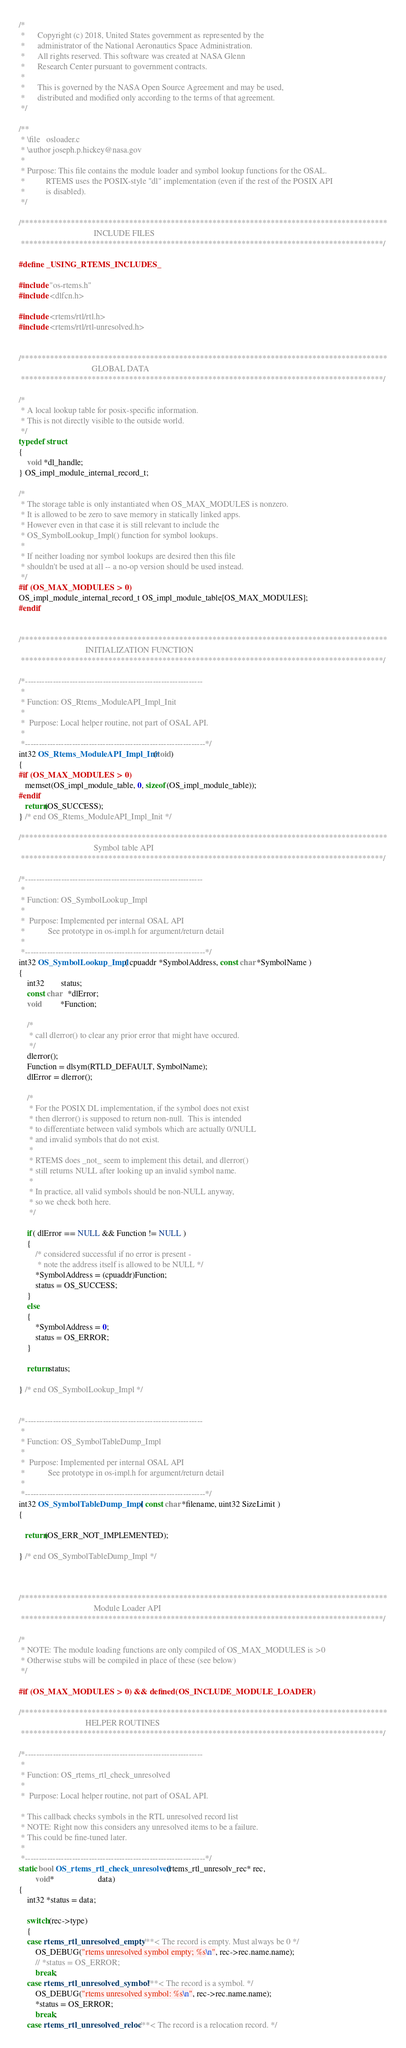<code> <loc_0><loc_0><loc_500><loc_500><_C_>/*
 *      Copyright (c) 2018, United States government as represented by the
 *      administrator of the National Aeronautics Space Administration.
 *      All rights reserved. This software was created at NASA Glenn
 *      Research Center pursuant to government contracts.
 *
 *      This is governed by the NASA Open Source Agreement and may be used,
 *      distributed and modified only according to the terms of that agreement.
 */

/**
 * \file   osloader.c
 * \author joseph.p.hickey@nasa.gov
 *
 * Purpose: This file contains the module loader and symbol lookup functions for the OSAL.
 *          RTEMS uses the POSIX-style "dl" implementation (even if the rest of the POSIX API
 *          is disabled).
 */

/****************************************************************************************
                                    INCLUDE FILES
 ***************************************************************************************/

#define _USING_RTEMS_INCLUDES_

#include "os-rtems.h"
#include <dlfcn.h>

#include <rtems/rtl/rtl.h>
#include <rtems/rtl/rtl-unresolved.h>


/****************************************************************************************
                                   GLOBAL DATA
 ***************************************************************************************/

/*
 * A local lookup table for posix-specific information.
 * This is not directly visible to the outside world.
 */
typedef struct
{
    void *dl_handle;
} OS_impl_module_internal_record_t;

/*
 * The storage table is only instantiated when OS_MAX_MODULES is nonzero.
 * It is allowed to be zero to save memory in statically linked apps.
 * However even in that case it is still relevant to include the
 * OS_SymbolLookup_Impl() function for symbol lookups.
 *
 * If neither loading nor symbol lookups are desired then this file
 * shouldn't be used at all -- a no-op version should be used instead.
 */
#if (OS_MAX_MODULES > 0)
OS_impl_module_internal_record_t OS_impl_module_table[OS_MAX_MODULES];
#endif


/****************************************************************************************
                                INITIALIZATION FUNCTION
 ***************************************************************************************/
                        
/*----------------------------------------------------------------
 *
 * Function: OS_Rtems_ModuleAPI_Impl_Init
 *
 *  Purpose: Local helper routine, not part of OSAL API.
 *
 *-----------------------------------------------------------------*/
int32 OS_Rtems_ModuleAPI_Impl_Init(void)
{
#if (OS_MAX_MODULES > 0)
   memset(OS_impl_module_table, 0, sizeof(OS_impl_module_table));
#endif
   return(OS_SUCCESS);
} /* end OS_Rtems_ModuleAPI_Impl_Init */

/****************************************************************************************
                                    Symbol table API
 ***************************************************************************************/
                        
/*----------------------------------------------------------------
 *
 * Function: OS_SymbolLookup_Impl
 *
 *  Purpose: Implemented per internal OSAL API
 *           See prototype in os-impl.h for argument/return detail
 *
 *-----------------------------------------------------------------*/
int32 OS_SymbolLookup_Impl( cpuaddr *SymbolAddress, const char *SymbolName )
{
    int32        status;
    const char   *dlError;
    void         *Function;

    /*
     * call dlerror() to clear any prior error that might have occured.
     */
    dlerror();
    Function = dlsym(RTLD_DEFAULT, SymbolName);
    dlError = dlerror();

    /*
     * For the POSIX DL implementation, if the symbol does not exist
     * then dlerror() is supposed to return non-null.  This is intended
     * to differentiate between valid symbols which are actually 0/NULL
     * and invalid symbols that do not exist.
     *
     * RTEMS does _not_ seem to implement this detail, and dlerror()
     * still returns NULL after looking up an invalid symbol name.
     *
     * In practice, all valid symbols should be non-NULL anyway,
     * so we check both here.
     */

    if( dlError == NULL && Function != NULL )
    {
        /* considered successful if no error is present -
         * note the address itself is allowed to be NULL */
        *SymbolAddress = (cpuaddr)Function;
        status = OS_SUCCESS;
    }
    else
    {
        *SymbolAddress = 0;
        status = OS_ERROR;
    }

    return status;

} /* end OS_SymbolLookup_Impl */

                        
/*----------------------------------------------------------------
 *
 * Function: OS_SymbolTableDump_Impl
 *
 *  Purpose: Implemented per internal OSAL API
 *           See prototype in os-impl.h for argument/return detail
 *
 *-----------------------------------------------------------------*/
int32 OS_SymbolTableDump_Impl ( const char *filename, uint32 SizeLimit )
{

   return(OS_ERR_NOT_IMPLEMENTED);

} /* end OS_SymbolTableDump_Impl */



/****************************************************************************************
                                    Module Loader API
 ***************************************************************************************/

/*
 * NOTE: The module loading functions are only compiled of OS_MAX_MODULES is >0
 * Otherwise stubs will be compiled in place of these (see below)
 */

#if (OS_MAX_MODULES > 0) && defined(OS_INCLUDE_MODULE_LOADER)

/****************************************************************************************
                                HELPER ROUTINES
 ***************************************************************************************/

/*----------------------------------------------------------------
 *
 * Function: OS_rtems_rtl_check_unresolved
 *
 *  Purpose: Local helper routine, not part of OSAL API.

 * This callback checks symbols in the RTL unresolved record list
 * NOTE: Right now this considers any unresolved items to be a failure.
 * This could be fine-tuned later.
 *
 *-----------------------------------------------------------------*/
static bool OS_rtems_rtl_check_unresolved (rtems_rtl_unresolv_rec* rec,
        void*                     data)
{
    int32 *status = data;

    switch(rec->type)
    {
    case rtems_rtl_unresolved_empty: /**< The record is empty. Must always be 0 */
        OS_DEBUG("rtems unresolved symbol empty; %s\n", rec->rec.name.name);
        // *status = OS_ERROR;
        break;
    case rtems_rtl_unresolved_symbol: /**< The record is a symbol. */
        OS_DEBUG("rtems unresolved symbol: %s\n", rec->rec.name.name);
        *status = OS_ERROR;
        break;
    case rtems_rtl_unresolved_reloc: /**< The record is a relocation record. */</code> 